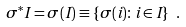Convert formula to latex. <formula><loc_0><loc_0><loc_500><loc_500>\sigma ^ { * } I = \sigma ( I ) \equiv \{ \sigma ( i ) \colon i \in I \} \ .</formula> 